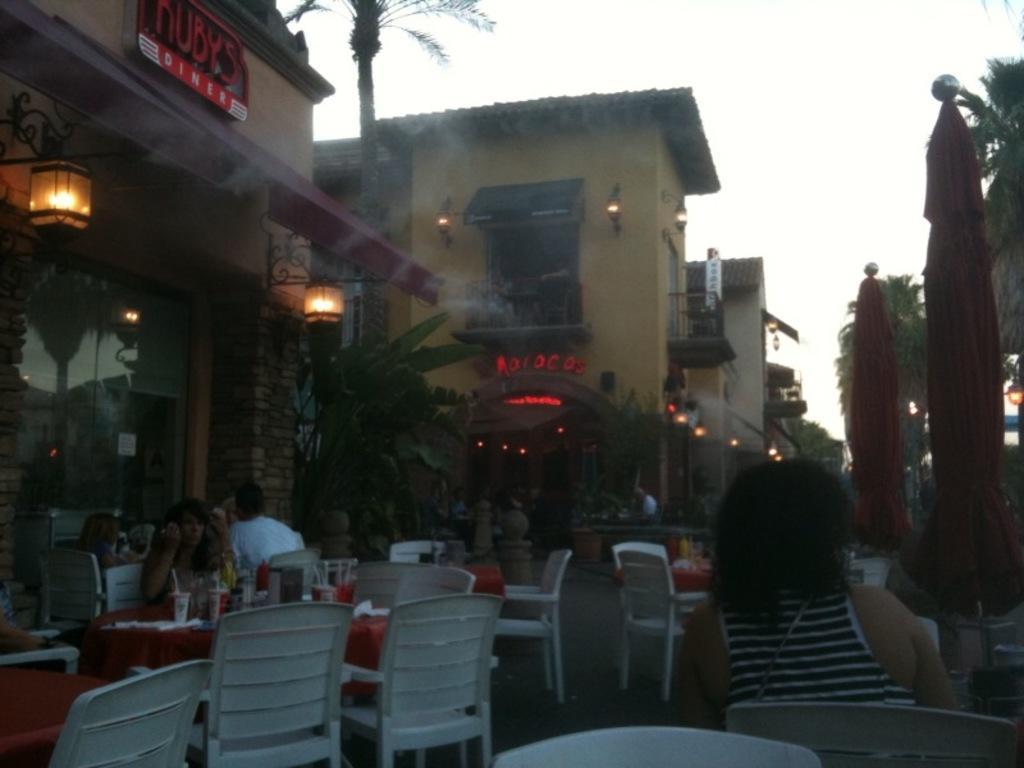Describe this image in one or two sentences. In this picture, we see many chairs and tables. Beside that, we see three people are sitting on the chairs. Beside that, there is a building and it might be a hotel. Beside that, there are buildings and trees. On the right side of the picture, we see trees and the flags in red color. At the top of the picture, we see the sky. This picture is clicked in the evening. 